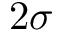Convert formula to latex. <formula><loc_0><loc_0><loc_500><loc_500>2 \sigma</formula> 